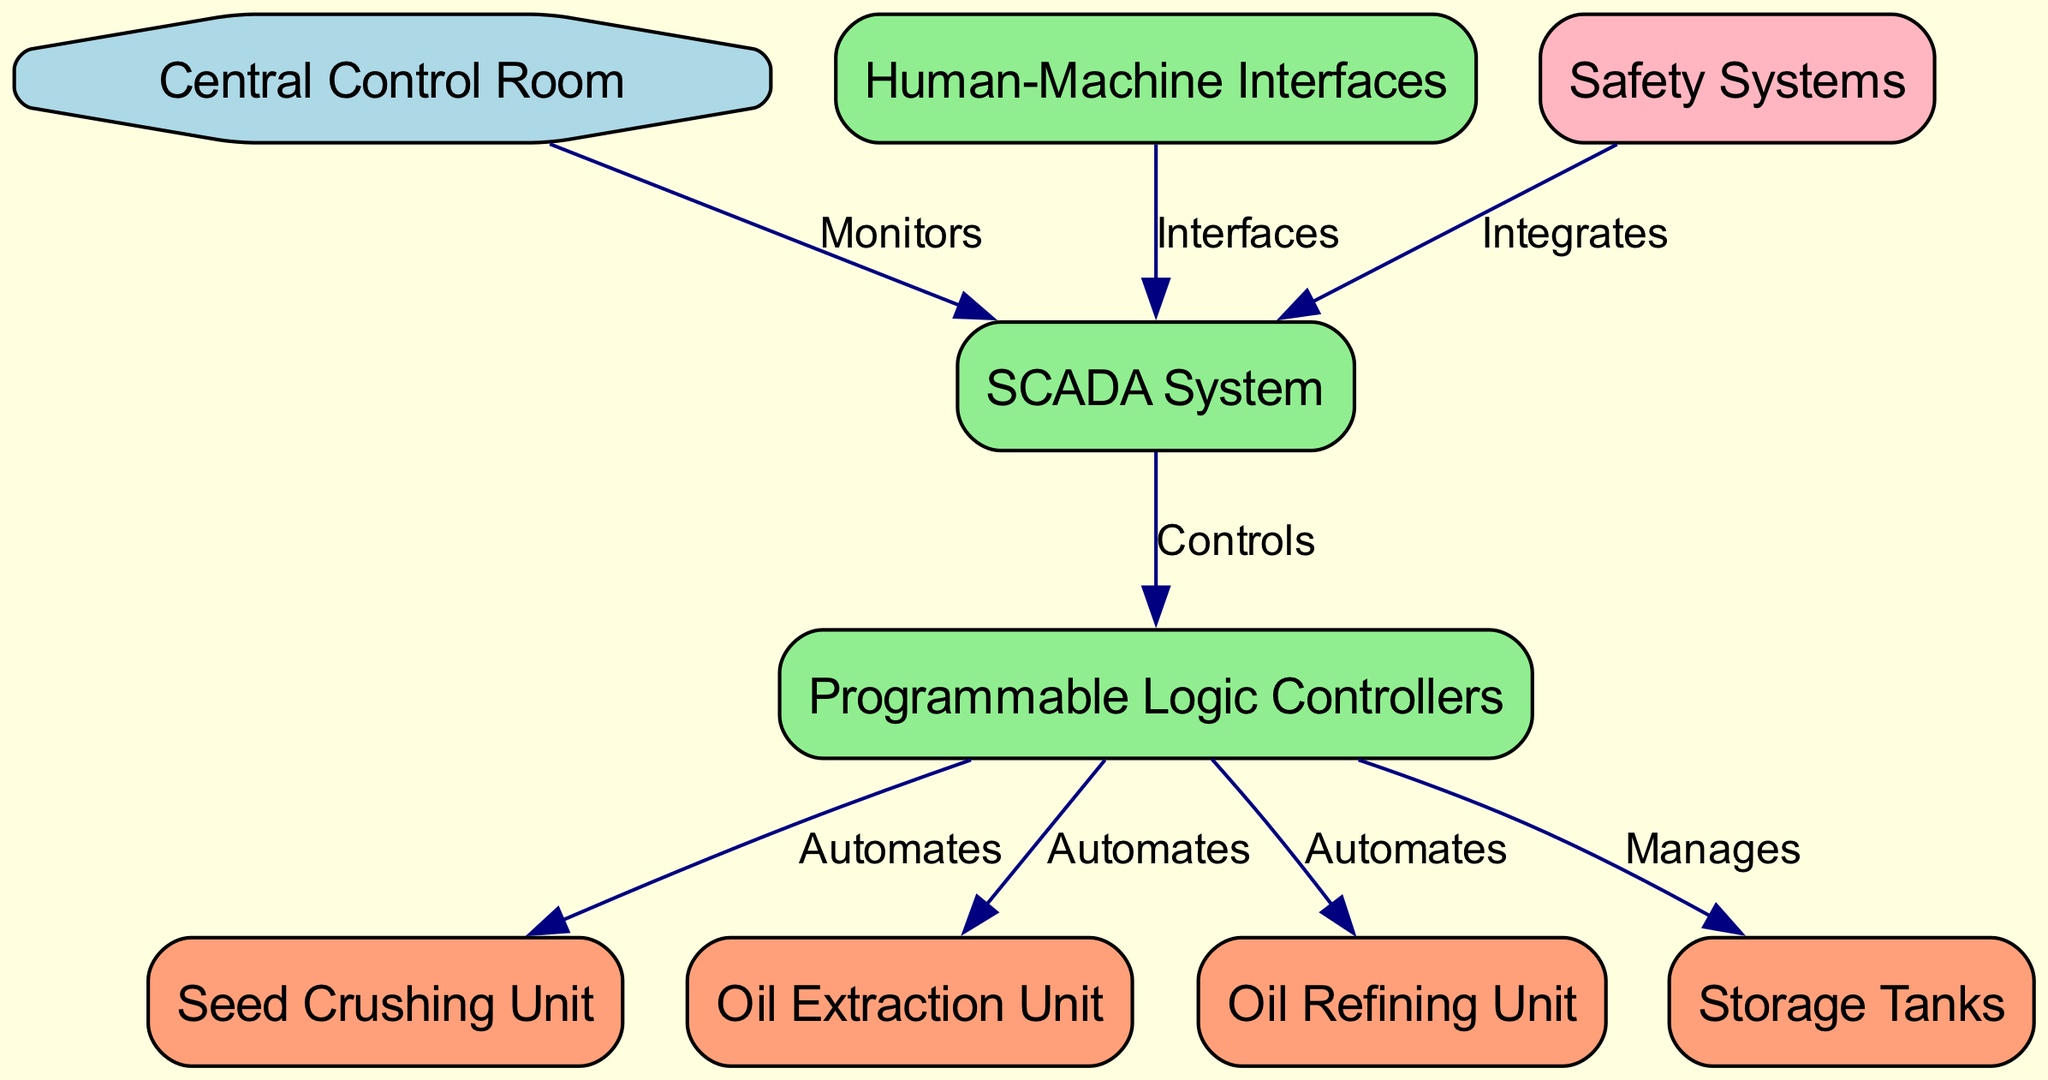What is the total number of nodes in the diagram? The diagram lists eight nodes, which are: Central Control Room, SCADA System, Programmable Logic Controllers, Human-Machine Interfaces, Seed Crushing Unit, Oil Extraction Unit, Oil Refining Unit, and Storage Tanks. Therefore, by counting these, we determine the total number of nodes.
Answer: 8 Which unit does the SCADA System control? According to the diagram, the SCADA System has edges labeled as "Controls" leading to the Programmable Logic Controllers, indicating that it controls PLCs. Thus, it's the immediate target it's designed to control in the system architecture.
Answer: Programmable Logic Controllers How many edges are connected to the Seed Crushing Unit? The diagram shows an edge labeled "Automates" from Programmable Logic Controllers to Seed Crushing Unit. This indicates that only one edge is connected to the Seed Crushing Unit, establishing its control through the PLCs.
Answer: 1 What is the relationship between the Central Control Room and the SCADA System? The diagram specifies an edge labeled "Monitors" between the Central Control Room and the SCADA System. This indicates that the Central Control Room monitors the SCADA System, highlighting its supervisory role within the control architecture.
Answer: Monitors Which node integrates with the SCADA System? The diagram features an edge labeled "Integrates" that connects the Safety Systems to the SCADA System. This indicates that the Safety Systems are integrated with the SCADA System, showing how safety measures are intertwined with the control process.
Answer: Safety Systems What unit is automated by the Programmable Logic Controllers aside from the Seed Crushing Unit? In addition to the Seed Crushing Unit, the diagram shows edges labeled as "Automates" connecting the Programmable Logic Controllers to both the Oil Extraction Unit and the Oil Refining Unit, indicating their orchestration for those operations as well.
Answer: Oil Extraction Unit and Oil Refining Unit What color is the node representing the Central Control Room? The Central Control Room node is represented in light blue according to the diagram's color coding for different types of nodes, highlighting its distinct role within the control architecture.
Answer: Light blue How does the Human-Machine Interface relate to the SCADA System? The diagram illustrates that the Human-Machine Interfaces have an edge labeled "Interfaces" directed towards the SCADA System, indicating that HMIs provide a means of interaction with the SCADA System for operators.
Answer: Interfaces 